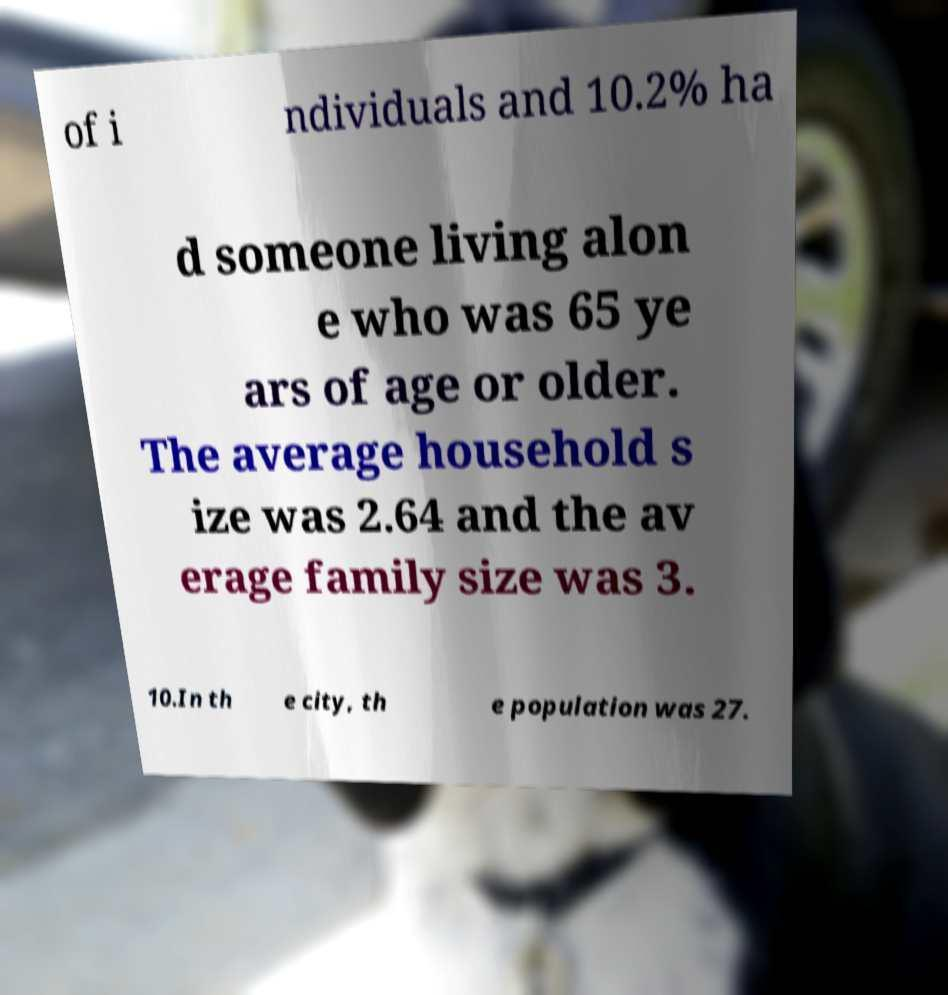Could you extract and type out the text from this image? of i ndividuals and 10.2% ha d someone living alon e who was 65 ye ars of age or older. The average household s ize was 2.64 and the av erage family size was 3. 10.In th e city, th e population was 27. 